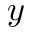Convert formula to latex. <formula><loc_0><loc_0><loc_500><loc_500>y</formula> 